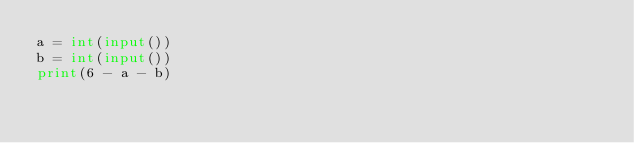Convert code to text. <code><loc_0><loc_0><loc_500><loc_500><_Python_>a = int(input())
b = int(input())
print(6 - a - b)</code> 